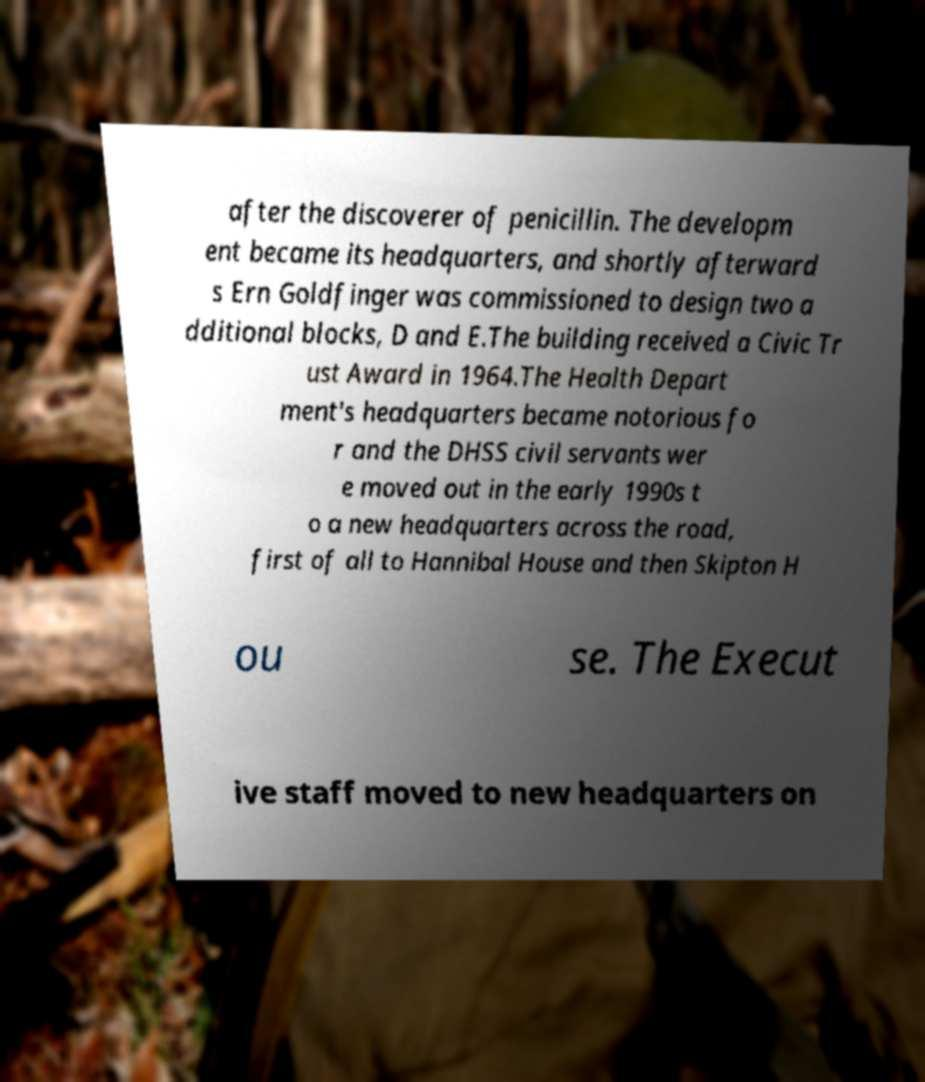Please identify and transcribe the text found in this image. after the discoverer of penicillin. The developm ent became its headquarters, and shortly afterward s Ern Goldfinger was commissioned to design two a dditional blocks, D and E.The building received a Civic Tr ust Award in 1964.The Health Depart ment's headquarters became notorious fo r and the DHSS civil servants wer e moved out in the early 1990s t o a new headquarters across the road, first of all to Hannibal House and then Skipton H ou se. The Execut ive staff moved to new headquarters on 